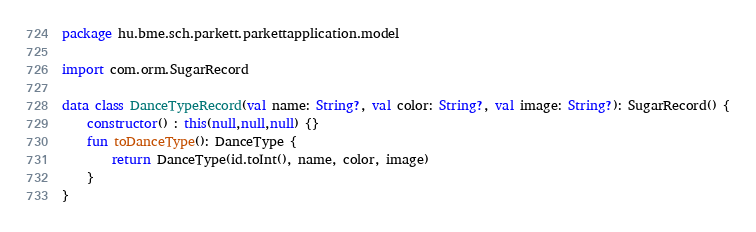Convert code to text. <code><loc_0><loc_0><loc_500><loc_500><_Kotlin_>package hu.bme.sch.parkett.parkettapplication.model

import com.orm.SugarRecord

data class DanceTypeRecord(val name: String?, val color: String?, val image: String?): SugarRecord() {
    constructor() : this(null,null,null) {}
    fun toDanceType(): DanceType {
        return DanceType(id.toInt(), name, color, image)
    }
}</code> 